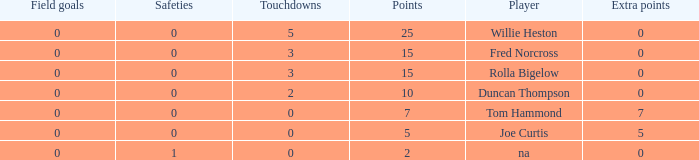How many Touchdowns have a Player of rolla bigelow, and an Extra points smaller than 0? None. 